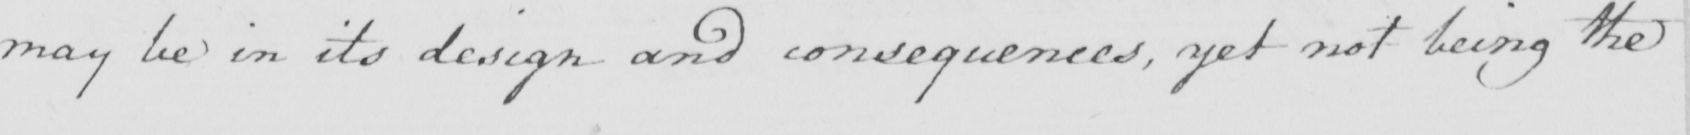What does this handwritten line say? may be in its design and consequences , yet not being the 